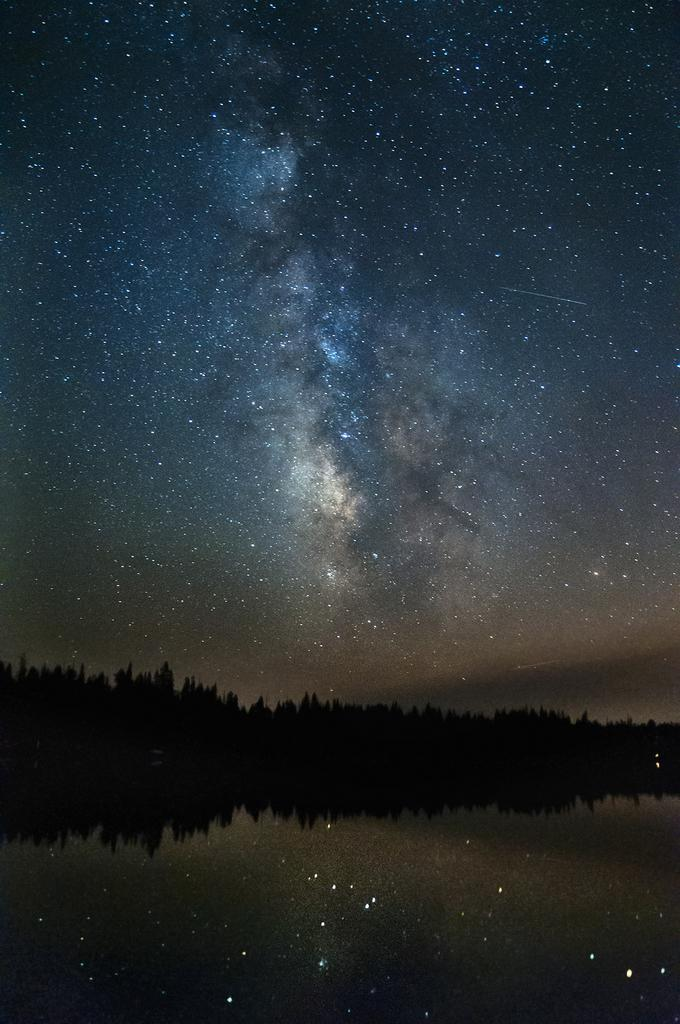What is visible in the image? Water, trees, and the sky are visible in the image. Can you describe the sky in the image? The sky is visible in the image, and stars are visible in the sky. Can you see any ants crawling on the trees in the image? There is no indication of ants in the image; it features water, trees, and the sky with visible stars. What type of butter can be seen melting on the leaves of the trees in the image? There is no butter present on the trees in the image. 